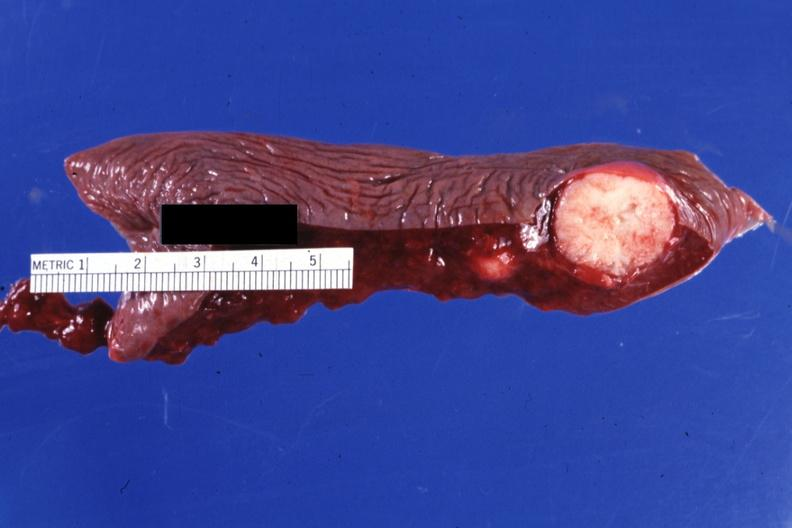what is present?
Answer the question using a single word or phrase. Hematologic 